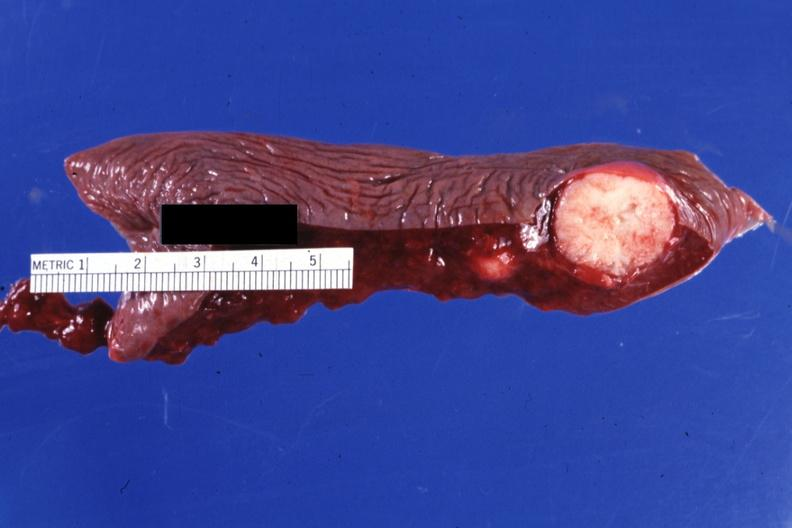what is present?
Answer the question using a single word or phrase. Hematologic 